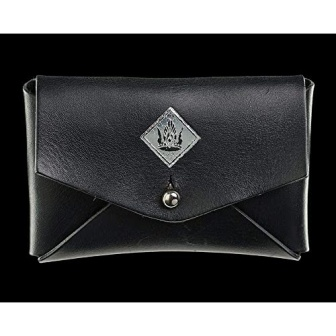What is this photo about? The image showcases a sophisticated black leather wallet, featured prominently against a dark background for a sleek and elegant look. The wallet is adorned with a distinct silver emblem in the shape of a diamond, incorporating a regal crown and wings design that suggests a touch of luxury or perhaps a specific brand identity. A silver button closure ensures the contents are securely held within. This finely crafted accessory likely appeals to those with a preference for upscale, minimalist designs who appreciate functionality coupled with stylish aesthetics. 